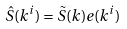<formula> <loc_0><loc_0><loc_500><loc_500>\hat { S } ( k ^ { i } ) = \tilde { S } ( k ) e ( k ^ { i } )</formula> 